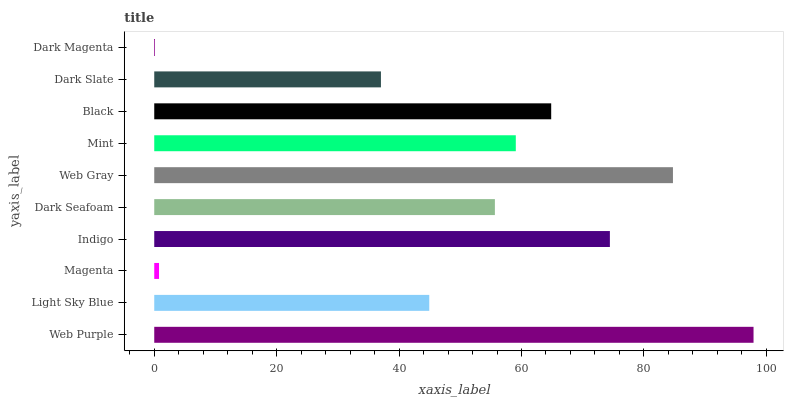Is Dark Magenta the minimum?
Answer yes or no. Yes. Is Web Purple the maximum?
Answer yes or no. Yes. Is Light Sky Blue the minimum?
Answer yes or no. No. Is Light Sky Blue the maximum?
Answer yes or no. No. Is Web Purple greater than Light Sky Blue?
Answer yes or no. Yes. Is Light Sky Blue less than Web Purple?
Answer yes or no. Yes. Is Light Sky Blue greater than Web Purple?
Answer yes or no. No. Is Web Purple less than Light Sky Blue?
Answer yes or no. No. Is Mint the high median?
Answer yes or no. Yes. Is Dark Seafoam the low median?
Answer yes or no. Yes. Is Indigo the high median?
Answer yes or no. No. Is Black the low median?
Answer yes or no. No. 